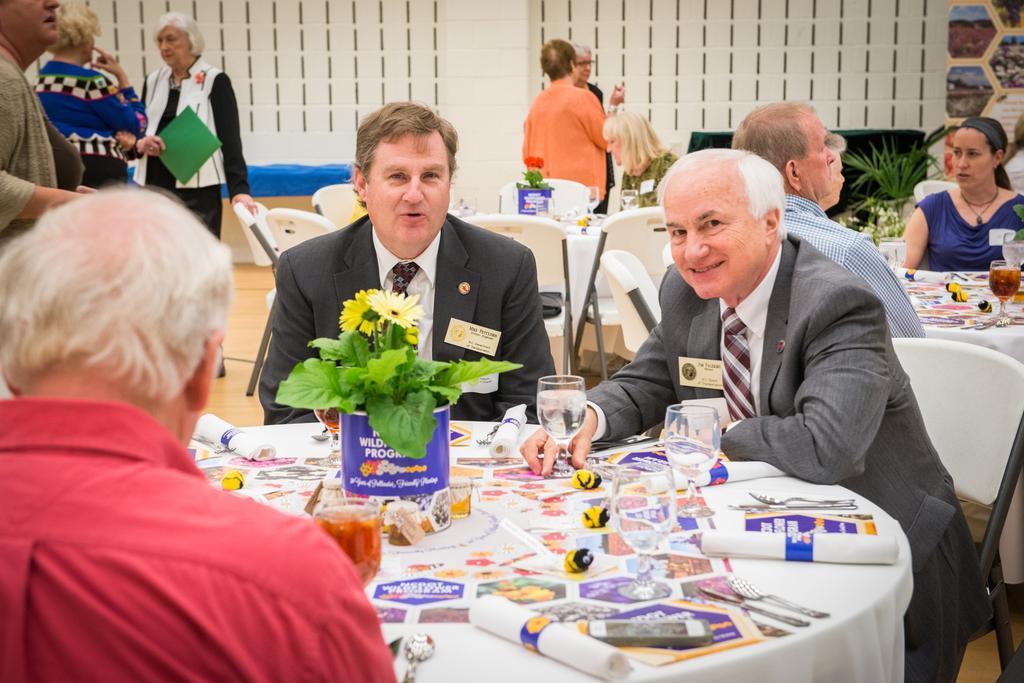How would you summarize this image in a sentence or two? In this picture there are three people sitting on a table. In the background we observe many people sitting on the table and few standing. 